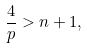<formula> <loc_0><loc_0><loc_500><loc_500>\frac { 4 } { p } > n + 1 ,</formula> 